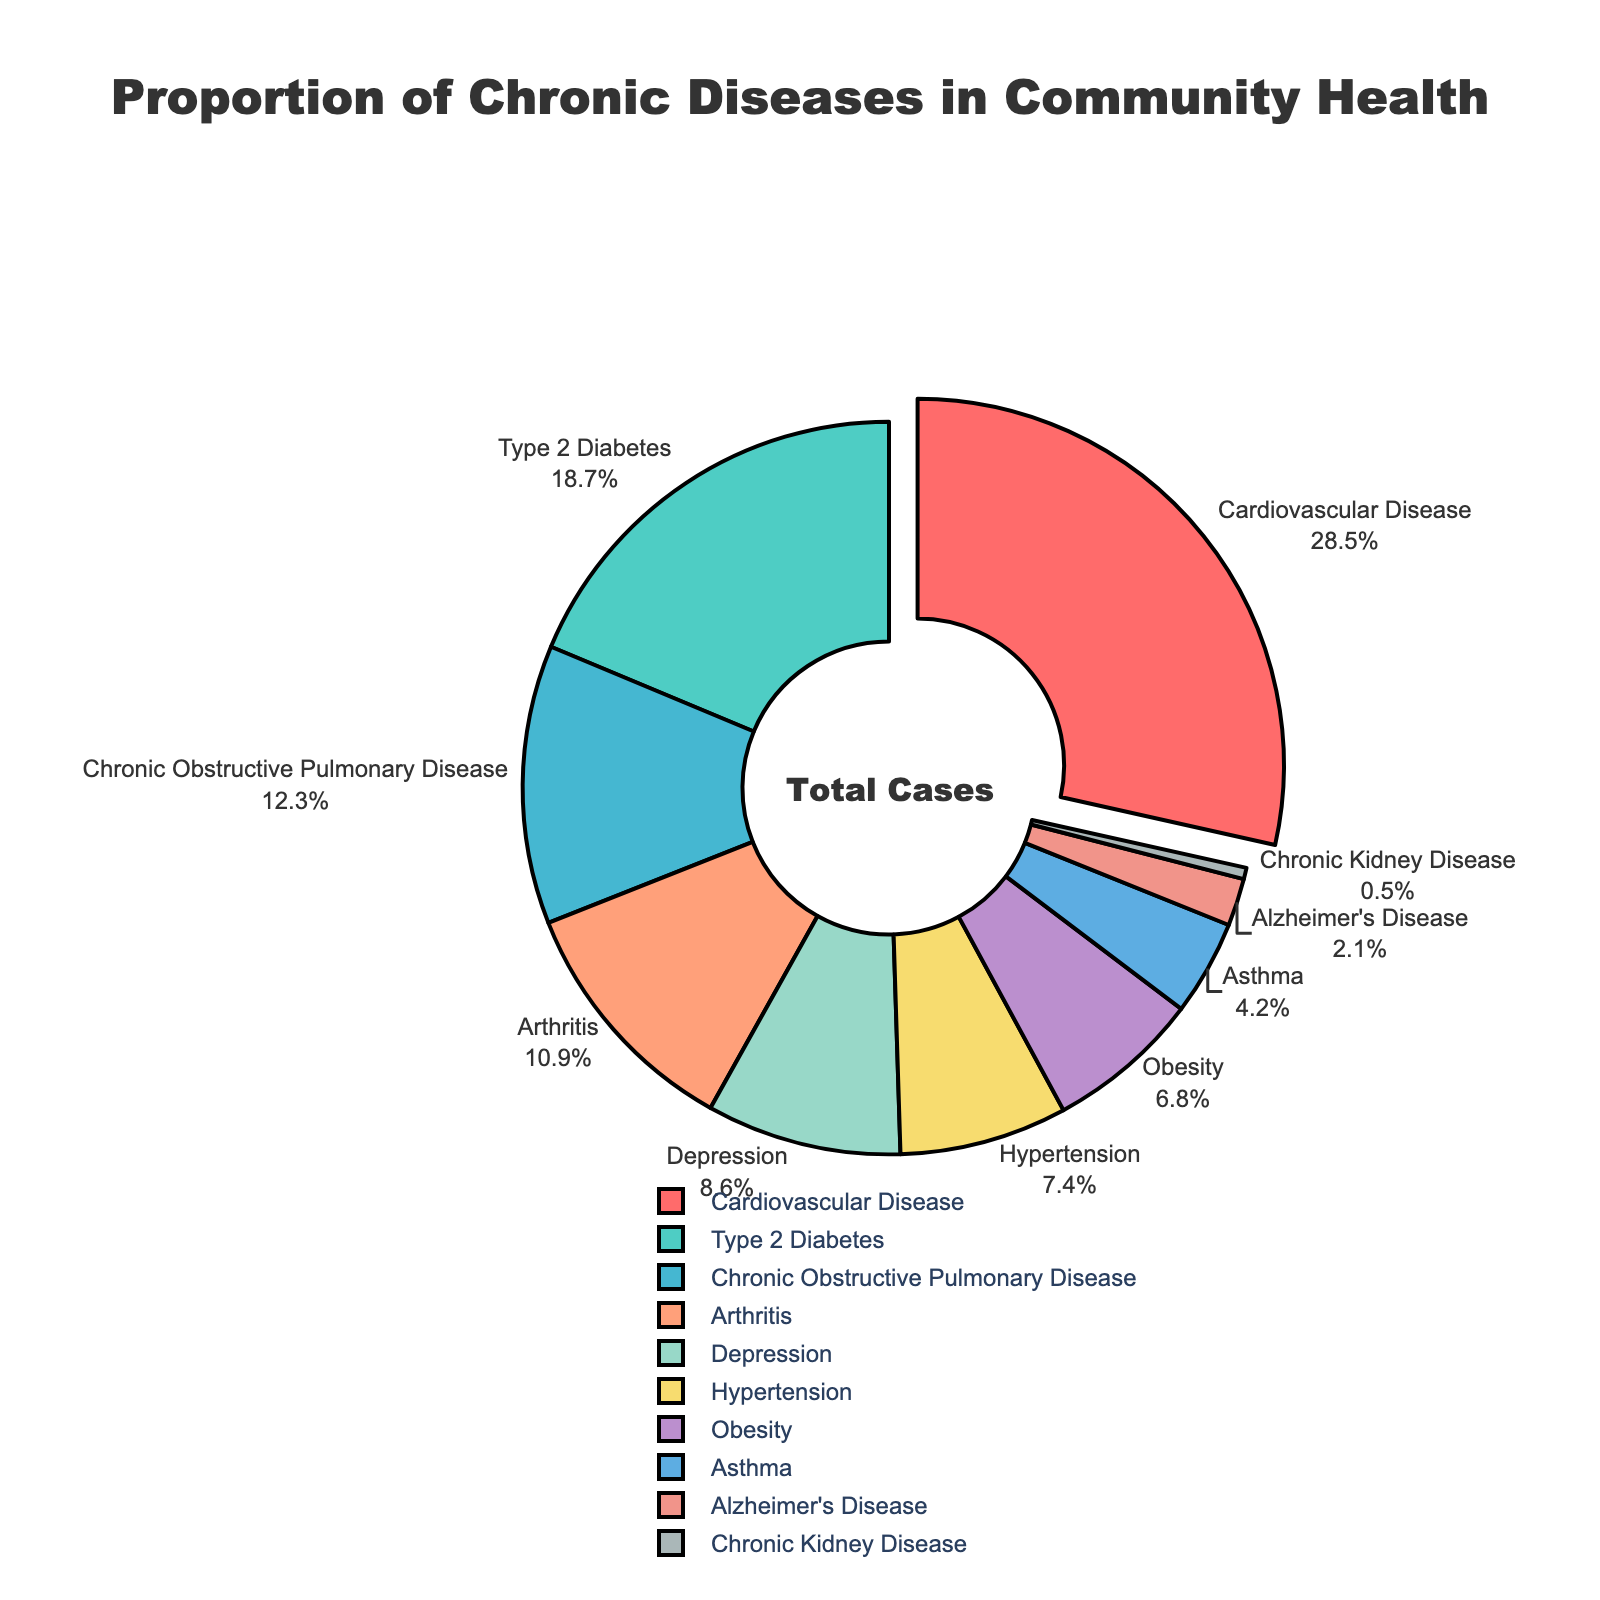How many diseases have a proportion greater than 10%? To answer this, we need to count the number of disease categories whose percentages are above 10%: Cardiovascular Disease (28.5%), Type 2 Diabetes (18.7%), Chronic Obstructive Pulmonary Disease (12.3%), and Arthritis (10.9%).
Answer: 4 Which disease has the smallest proportion? By comparing all the proportions, we can see that Chronic Kidney Disease has the smallest percentage at 0.5%.
Answer: Chronic Kidney Disease What is the total proportion of Type 2 Diabetes and Hypertension? Add the percentages of Type 2 Diabetes (18.7%) and Hypertension (7.4%): 18.7 + 7.4 = 26.1%
Answer: 26.1% Is the proportion of Cardiovascular Disease greater than the combined proportions of Asthma and Alzheimer's Disease? Cardiovascular Disease has a proportion of 28.5%. The combined proportion of Asthma (4.2%) and Alzheimer's Disease (2.1%) is 6.3%. Since 28.5 > 6.3, the answer is yes.
Answer: Yes Which chronic disease occupies the largest segment, and what is its proportion? From the pie chart, the segment with the largest proportion is Cardiovascular Disease, with a proportion of 28.5%.
Answer: Cardiovascular Disease, 28.5% What is the difference between the proportions of Arthritis and Obesity? Subtract the percentage of Obesity (6.8%) from Arthritis (10.9%): 10.9 - 6.8 = 4.1%
Answer: 4.1% How many diseases have a proportion less than 5%? Count the diseases with percentages below 5%: Asthma (4.2%), Alzheimer's Disease (2.1%), and Chronic Kidney Disease (0.5%).
Answer: 3 Which chronic disease's segment is colored green in the chart? To find this, we identify the color green, which corresponds to Chronic Obstructive Pulmonary Disease.
Answer: Chronic Obstructive Pulmonary Disease If we were to combine the proportions of Depression and Chronic Kidney Disease, would this new category exceed the proportion of any existing disease? Adding the percentages of Depression (8.6%) and Chronic Kidney Disease (0.5%) gives 9.1%, which would only exceed the proportions of Hypertension (7.4%) and Obesity (6.8%) among the existing diseases.
Answer: No What is the average proportion of Hypertension and Asthma? Add the percentages of Hypertension (7.4%) and Asthma (4.2%) and divide by 2: (7.4 + 4.2) / 2 = 5.8%
Answer: 5.8% 